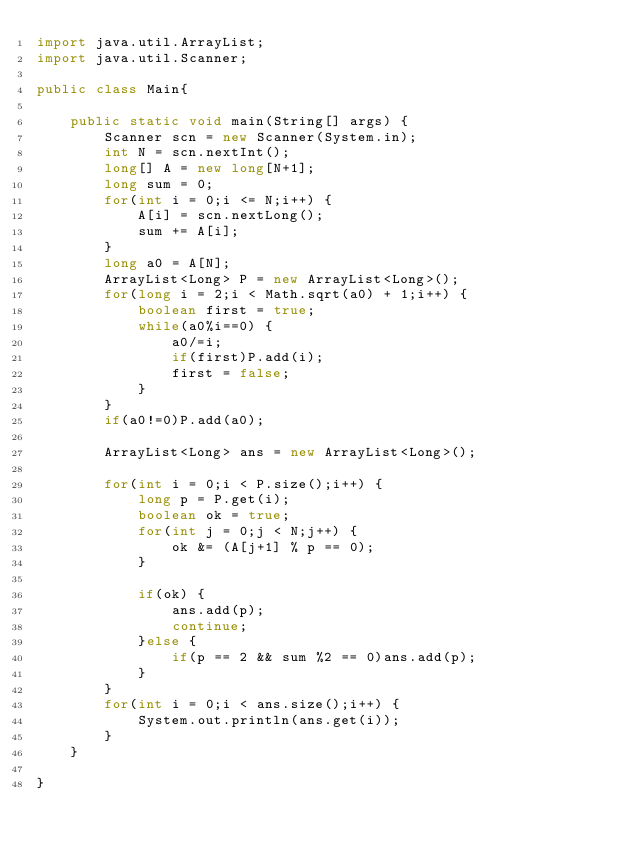Convert code to text. <code><loc_0><loc_0><loc_500><loc_500><_Java_>import java.util.ArrayList;
import java.util.Scanner;

public class Main{

	public static void main(String[] args) {
		Scanner scn = new Scanner(System.in);
		int N = scn.nextInt();
		long[] A = new long[N+1];
		long sum = 0;
		for(int i = 0;i <= N;i++) {
			A[i] = scn.nextLong();
			sum += A[i];
		}
		long a0 = A[N];
		ArrayList<Long> P = new ArrayList<Long>();
		for(long i = 2;i < Math.sqrt(a0) + 1;i++) {
			boolean first = true;
			while(a0%i==0) {
				a0/=i;
				if(first)P.add(i);
				first = false;
			}
		}
		if(a0!=0)P.add(a0);

		ArrayList<Long> ans = new ArrayList<Long>();

		for(int i = 0;i < P.size();i++) {
			long p = P.get(i);
			boolean ok = true;
			for(int j = 0;j < N;j++) {
				ok &= (A[j+1] % p == 0);
			}

			if(ok) {
				ans.add(p);
				continue;
			}else {
				if(p == 2 && sum %2 == 0)ans.add(p);
			}
		}
		for(int i = 0;i < ans.size();i++) {
			System.out.println(ans.get(i));
		}
	}

}
</code> 